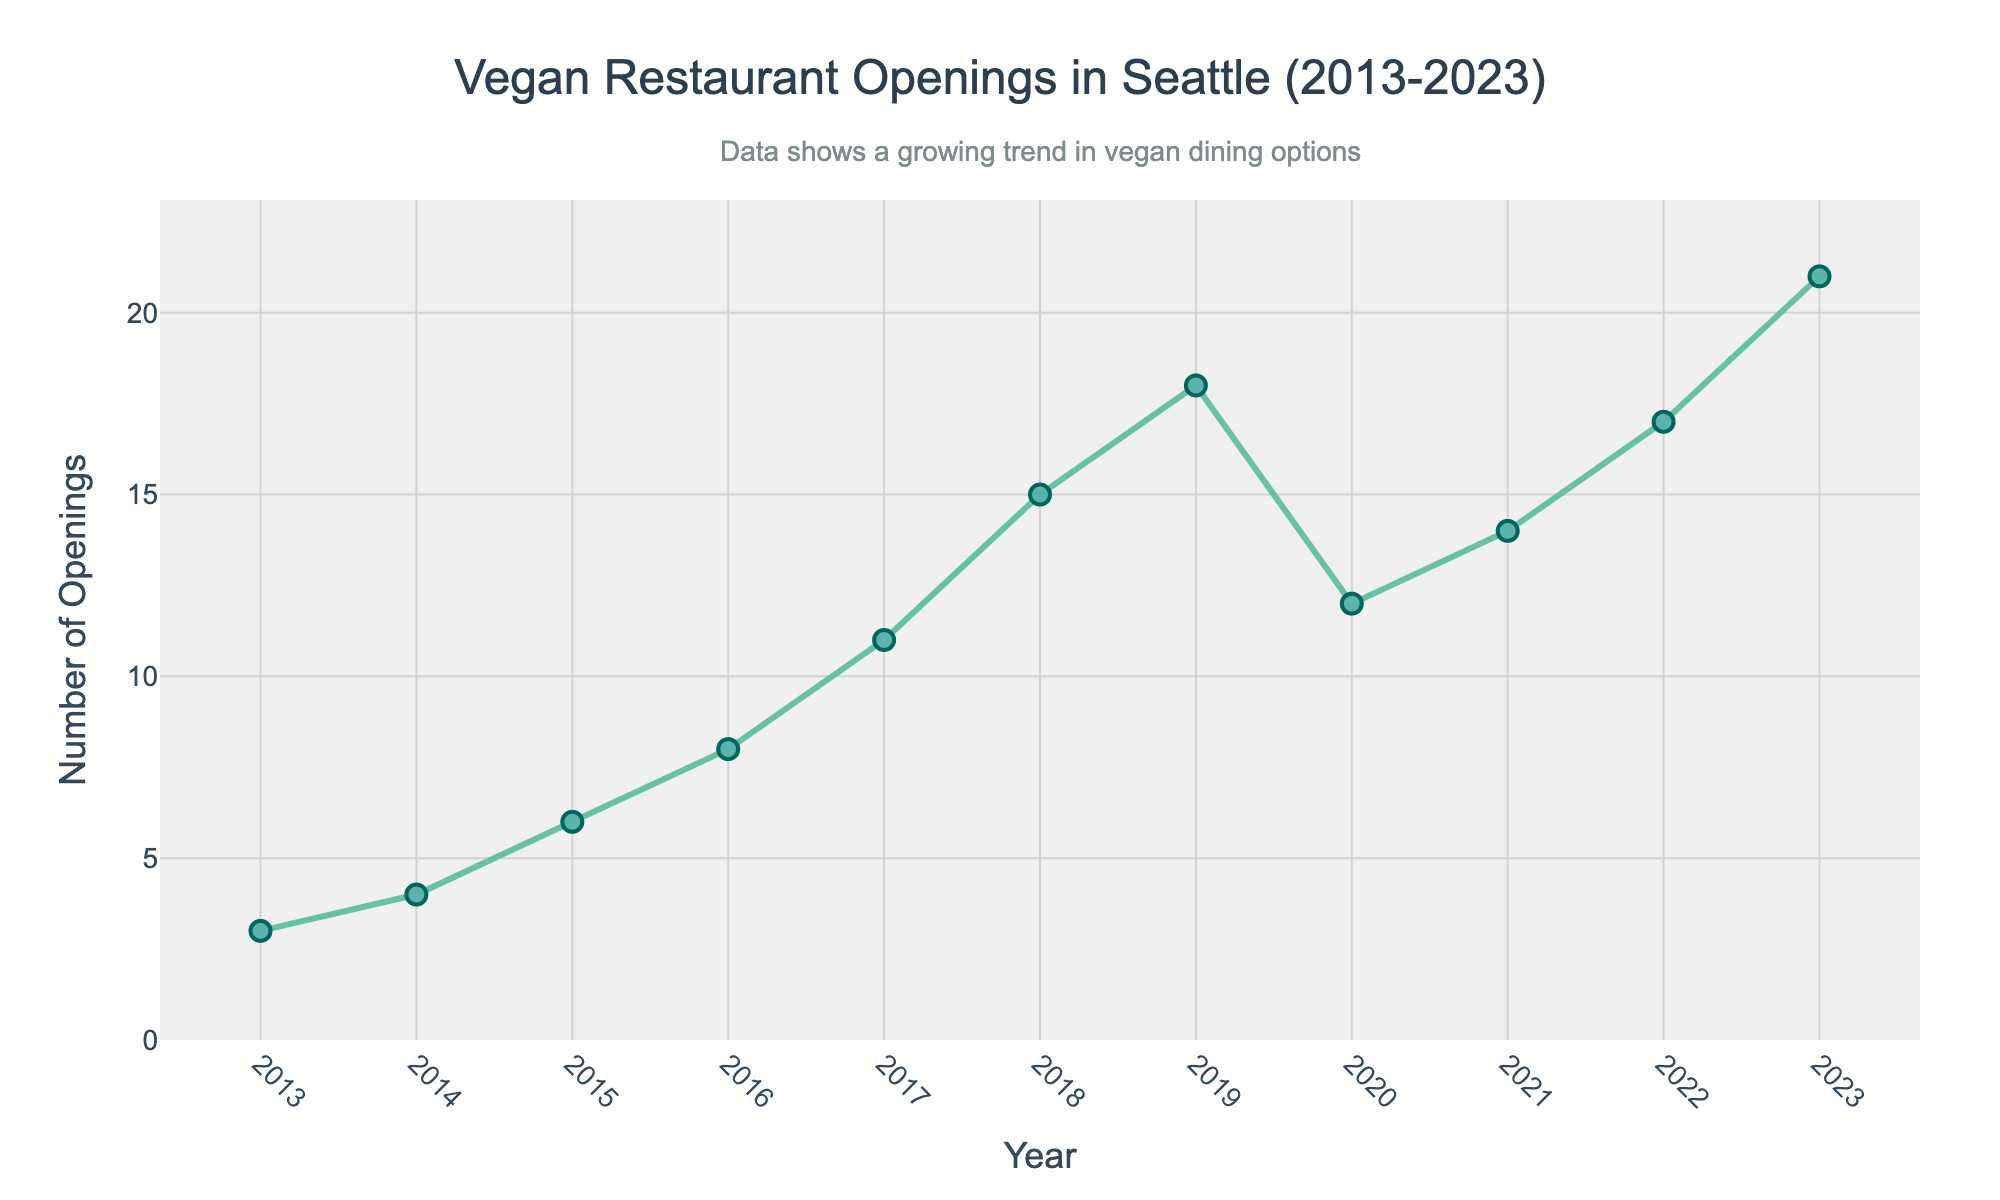what's the average number of vegan restaurant openings per year from 2013 to 2023? Sum the number of openings from 2013 to 2023 and then divide by the number of years. (3 + 4 + 6 + 8 + 11 + 15 + 18 + 12 + 14 + 17 + 21) = 129. There are 11 years from 2013 to 2023, so the average is 129 / 11 = 11.73
Answer: 11.73 Which year had the highest number of vegan restaurant openings? The highest point in the chart corresponds to 2023, with 21 openings.
Answer: 2023 Compare the number of vegan restaurant openings in 2017 and 2020. Which year had fewer openings? In 2017, there were 11 openings, and in 2020, there were 12. Therefore, 2017 had fewer openings.
Answer: 2017 What's the total number of vegan restaurant openings in the first half of the displayed time period (2013-2018)? Sum the number of openings from 2013 to 2018, which are (3 + 4 + 6 + 8 + 11 + 15) = 47.
Answer: 47 By how much did the number of vegan restaurant openings change from 2019 to 2020? Subtract the number of 2020 openings from the number of 2019 openings: 18 - 12 = 6.
Answer: 6 Which year saw the highest increase in the number of restaurant openings compared to the previous year? Calculate the yearly differences: 2014-2013 (4 - 3 = 1), 2015-2014 (6 - 4 = 2), 2016-2015 (8 - 6 = 2), 2017-2016 (11 - 8 = 3), 2018-2017 (15 - 11 = 4), 2019-2018 (18 - 15 = 3), 2020-2019 (12 - 18 = -6), 2021-2020 (14 - 12 = 2), 2022-2021 (17 - 14 = 3), 2023-2022 (21 - 17 = 4). The highest increase is 2018 to 2017 and 2023 to 2022, both with an increase of 4 openings.
Answer: 2018 and 2023 What's the median number of vegan restaurant openings from 2013 to 2023? Arrange the values in ascending order: (3, 4, 6, 8, 11, 12, 14, 15, 17, 18, 21). The median (middle value in the ordered list) is 12.
Answer: 12 What is the trend in vegan restaurant openings from 2013 to 2019? The number of openings increases every year from 2013 (3 openings) to 2019 (18 openings), showing a clear upward trend.
Answer: Upward trend 